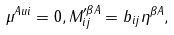<formula> <loc_0><loc_0><loc_500><loc_500>\mu ^ { A u i } = 0 , M _ { i j } ^ { \prime \beta A } = b _ { i j } \eta ^ { \beta A } ,</formula> 